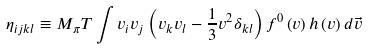<formula> <loc_0><loc_0><loc_500><loc_500>\eta _ { i j k l } \equiv M _ { \pi } { T } \int v _ { i } v _ { j } \left ( v _ { k } v _ { l } - \frac { 1 } { 3 } v ^ { 2 } \delta _ { k l } \right ) f ^ { 0 } \left ( v \right ) h \left ( v \right ) d \vec { v }</formula> 